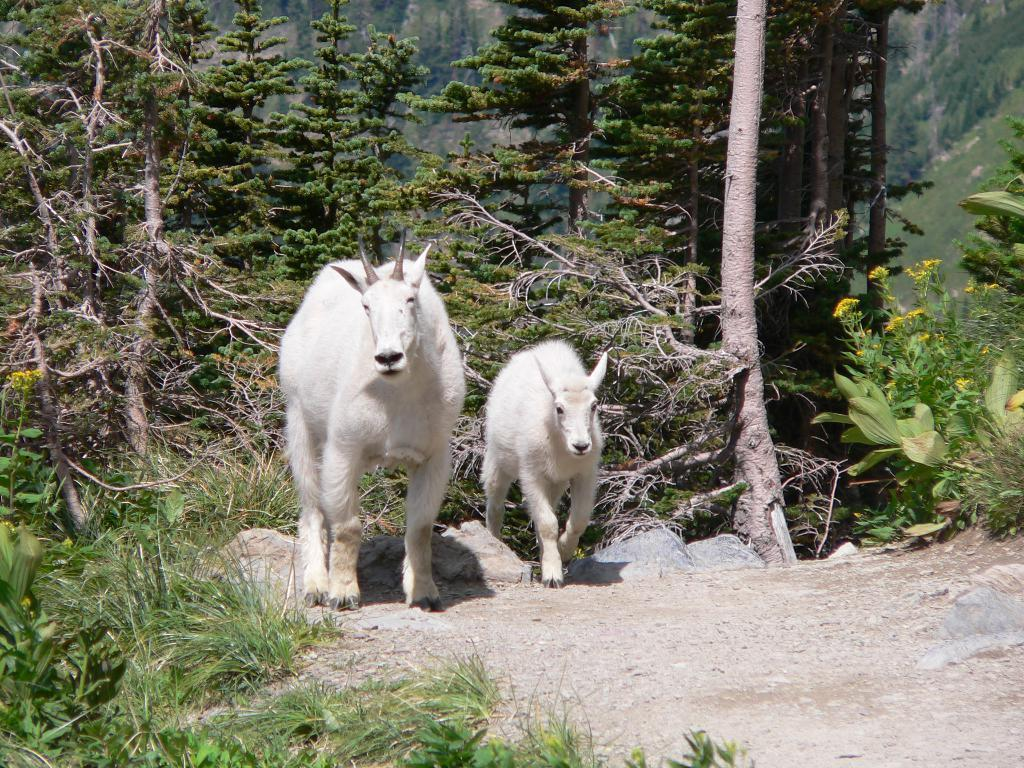How many goats are in the image? There are two goats in the image. Where are the goats located? The goats are on the ground. What type of vegetation is present in the image? There is grass and plants in the image. What can be seen in the background of the image? The background of the image includes trees and plants with flowers. How does the goat in the image get the attention of the wilderness? The image does not depict the goat getting the attention of the wilderness, as there is no wilderness present in the image. 